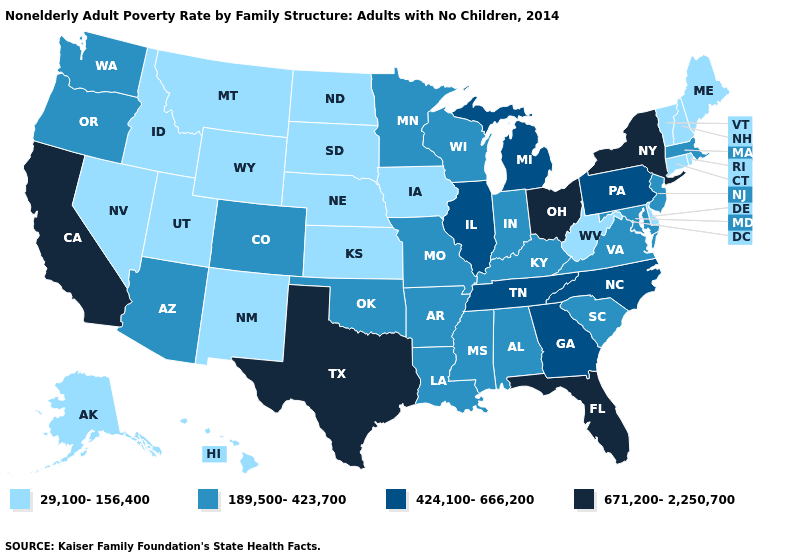Does Hawaii have the lowest value in the West?
Concise answer only. Yes. Which states have the lowest value in the USA?
Quick response, please. Alaska, Connecticut, Delaware, Hawaii, Idaho, Iowa, Kansas, Maine, Montana, Nebraska, Nevada, New Hampshire, New Mexico, North Dakota, Rhode Island, South Dakota, Utah, Vermont, West Virginia, Wyoming. Name the states that have a value in the range 424,100-666,200?
Answer briefly. Georgia, Illinois, Michigan, North Carolina, Pennsylvania, Tennessee. Name the states that have a value in the range 424,100-666,200?
Give a very brief answer. Georgia, Illinois, Michigan, North Carolina, Pennsylvania, Tennessee. Does Texas have the same value as Delaware?
Short answer required. No. What is the value of Louisiana?
Keep it brief. 189,500-423,700. What is the value of Ohio?
Write a very short answer. 671,200-2,250,700. Name the states that have a value in the range 424,100-666,200?
Quick response, please. Georgia, Illinois, Michigan, North Carolina, Pennsylvania, Tennessee. Name the states that have a value in the range 424,100-666,200?
Quick response, please. Georgia, Illinois, Michigan, North Carolina, Pennsylvania, Tennessee. Does the first symbol in the legend represent the smallest category?
Concise answer only. Yes. What is the lowest value in the South?
Concise answer only. 29,100-156,400. Among the states that border Washington , which have the highest value?
Concise answer only. Oregon. How many symbols are there in the legend?
Answer briefly. 4. Name the states that have a value in the range 29,100-156,400?
Quick response, please. Alaska, Connecticut, Delaware, Hawaii, Idaho, Iowa, Kansas, Maine, Montana, Nebraska, Nevada, New Hampshire, New Mexico, North Dakota, Rhode Island, South Dakota, Utah, Vermont, West Virginia, Wyoming. 